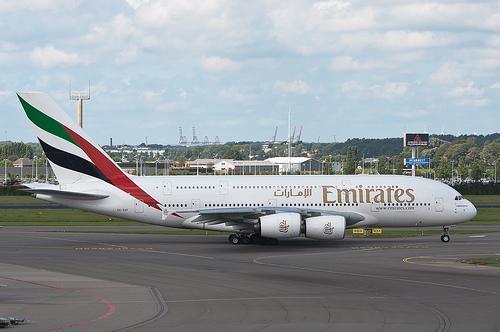How many planes are there?
Give a very brief answer. 1. 